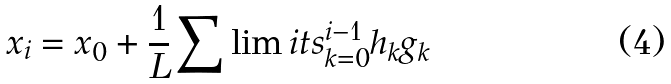Convert formula to latex. <formula><loc_0><loc_0><loc_500><loc_500>x _ { i } = x _ { 0 } + \frac { 1 } { L } \sum \lim i t s _ { k = 0 } ^ { i - 1 } h _ { k } g _ { k }</formula> 